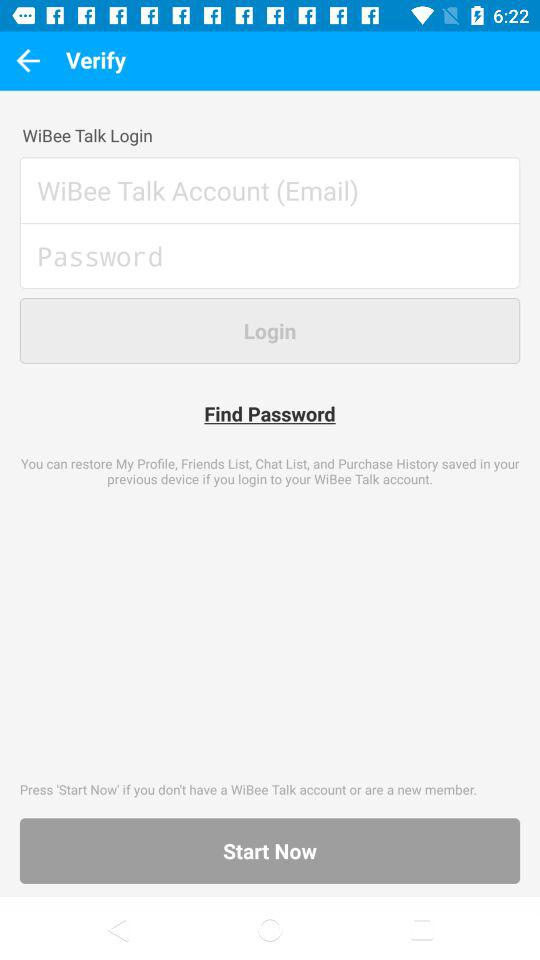What is the name of the application? The name of the application is "WiBee Talk". 